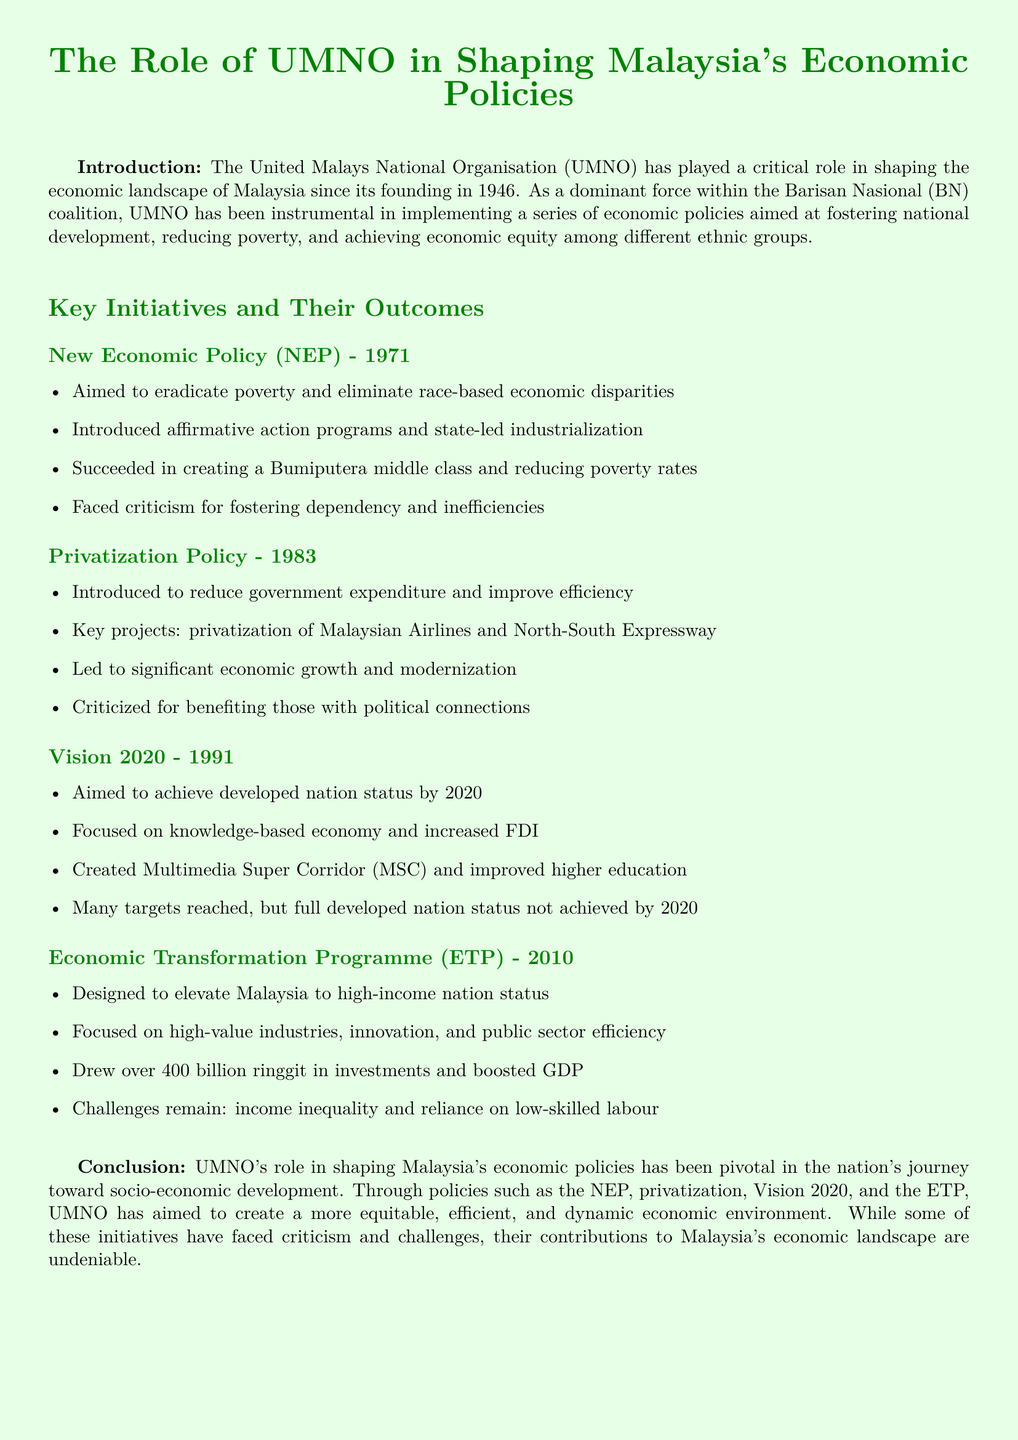What was the primary aim of the New Economic Policy? The document states that the NEP aimed to eradicate poverty and eliminate race-based economic disparities.
Answer: Eradicate poverty and eliminate race-based economic disparities When was the Privatization Policy introduced? The document specifies that the Privatization Policy was introduced in 1983.
Answer: 1983 What major project was included in the Privatization Policy? The document mentions the privatization of Malaysian Airlines as a key project under this policy.
Answer: Malaysian Airlines What was the goal of Vision 2020? The document indicates that the goal of Vision 2020 was to achieve developed nation status by 2020.
Answer: Achieve developed nation status by 2020 How much investment did the Economic Transformation Programme draw in? According to the document, the ETP drew over 400 billion ringgit in investments.
Answer: Over 400 billion ringgit What major challenge is noted in the Economic Transformation Programme? The document states that income inequality and reliance on low-skilled labour remain challenges.
Answer: Income inequality and reliance on low-skilled labour Which initiative aimed to create a Bumiputera middle class? The document states that the New Economic Policy aimed to create a Bumiputera middle class.
Answer: New Economic Policy How did UMNO's economic policies impact poverty rates? The document notes that the NEP succeeded in reducing poverty rates.
Answer: Reduced poverty rates What is a key criticism of the Privatization Policy? The document cites criticism for benefiting those with political connections as a key issue.
Answer: Benefiting those with political connections 